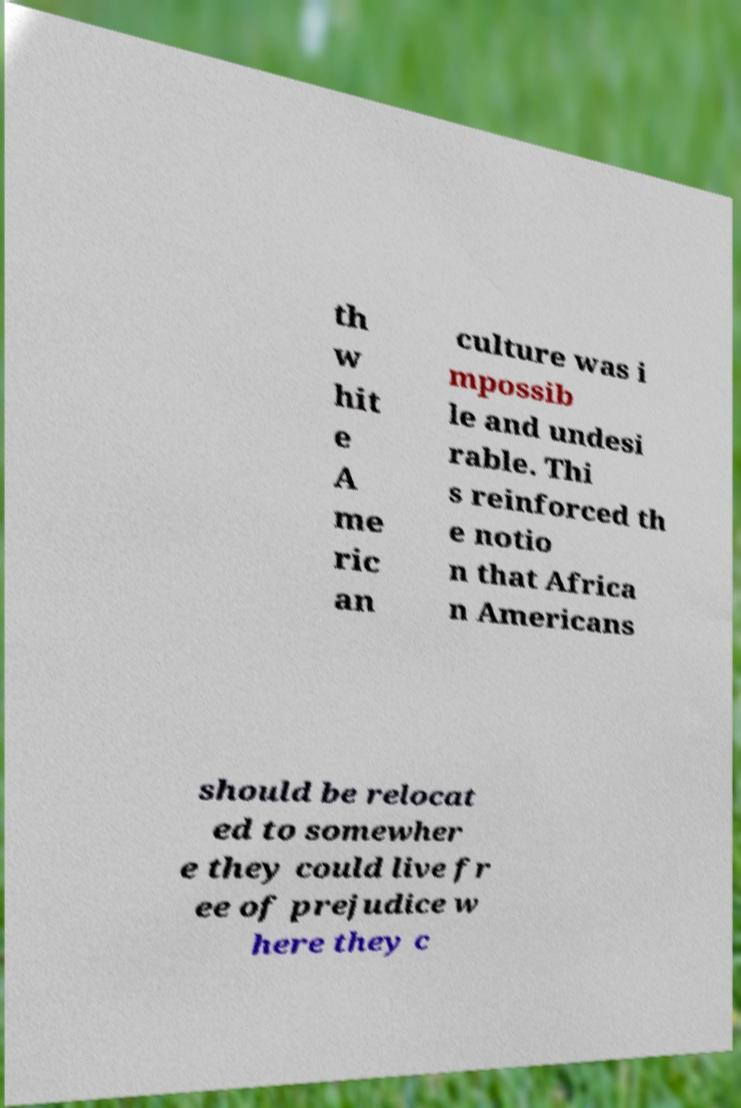There's text embedded in this image that I need extracted. Can you transcribe it verbatim? th w hit e A me ric an culture was i mpossib le and undesi rable. Thi s reinforced th e notio n that Africa n Americans should be relocat ed to somewher e they could live fr ee of prejudice w here they c 